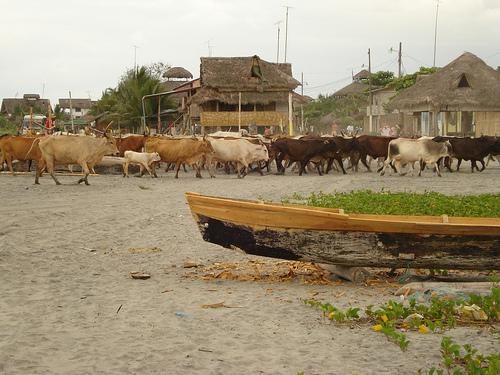Question: what are the animals?
Choices:
A. Sheep.
B. Zebras.
C. Cattle.
D. Giraffes.
Answer with the letter. Answer: C Question: what covers the huts?
Choices:
A. Hay.
B. Thatched roofs.
C. A tarp.
D. Twigs.
Answer with the letter. Answer: B 